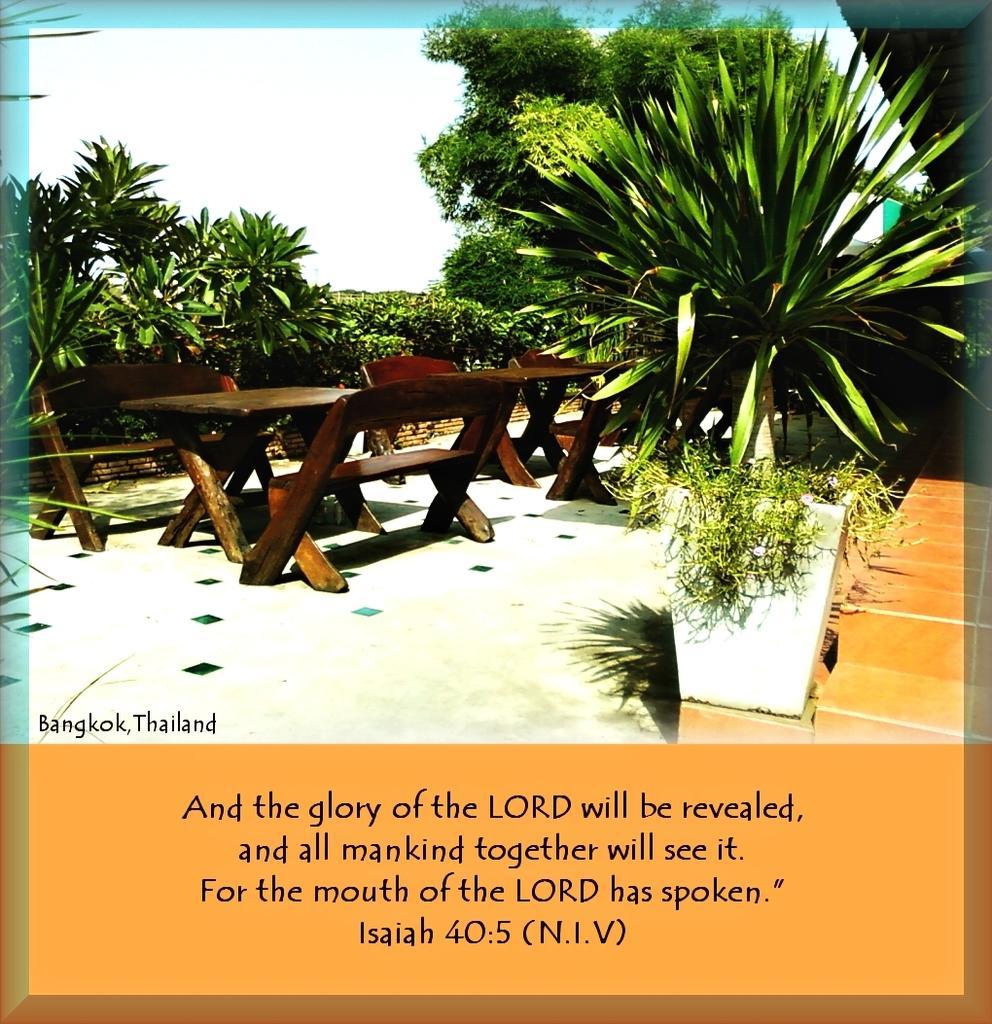How would you summarize this image in a sentence or two? We can see poster,in this poster we can see tables,benches,trees,plants and sky. Bottom of the image we can see text. 